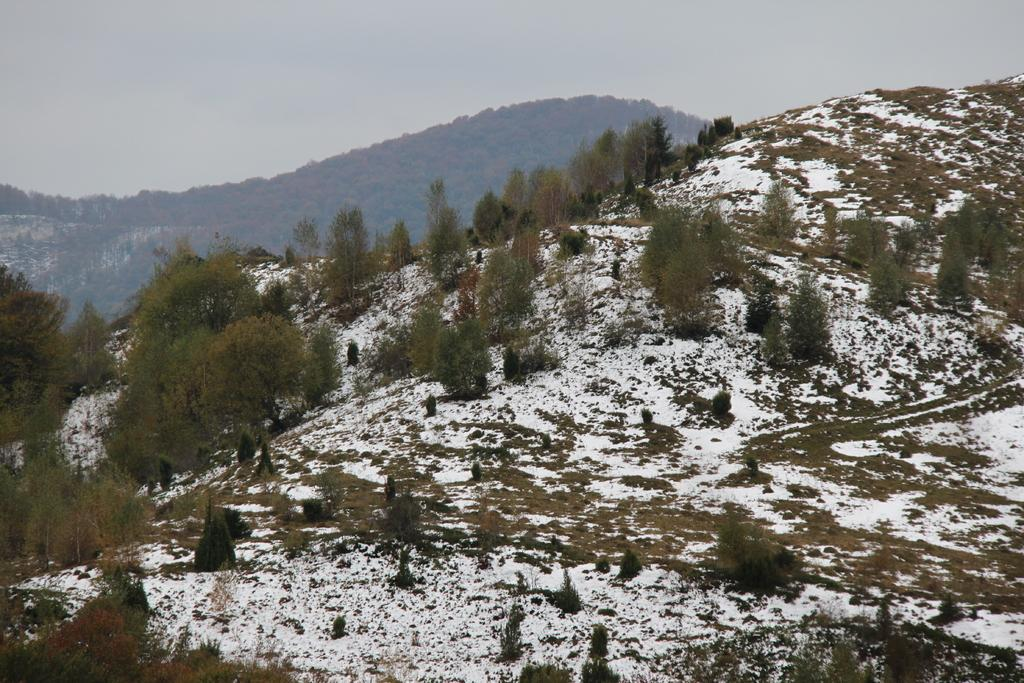What type of weather condition is depicted in the image? There is snow in the image, indicating a cold or wintry weather condition. What can be seen in the background of the image? There are trees and the sky visible in the background of the image. What type of haircut is the grass receiving in the image? There is no grass present in the image, and therefore no haircut can be observed. 